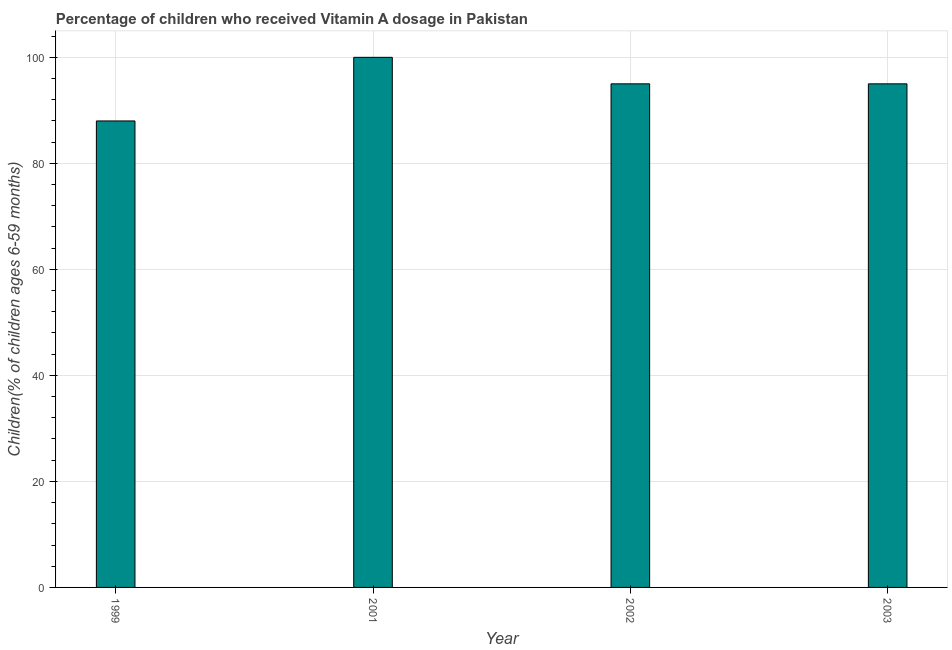Does the graph contain grids?
Keep it short and to the point. Yes. What is the title of the graph?
Make the answer very short. Percentage of children who received Vitamin A dosage in Pakistan. What is the label or title of the Y-axis?
Provide a succinct answer. Children(% of children ages 6-59 months). What is the vitamin a supplementation coverage rate in 2001?
Offer a terse response. 100. In which year was the vitamin a supplementation coverage rate minimum?
Provide a succinct answer. 1999. What is the sum of the vitamin a supplementation coverage rate?
Provide a succinct answer. 378. What is the difference between the vitamin a supplementation coverage rate in 2002 and 2003?
Your answer should be very brief. 0. What is the average vitamin a supplementation coverage rate per year?
Your response must be concise. 94. What is the median vitamin a supplementation coverage rate?
Your answer should be very brief. 95. Do a majority of the years between 1999 and 2003 (inclusive) have vitamin a supplementation coverage rate greater than 32 %?
Your response must be concise. Yes. What is the ratio of the vitamin a supplementation coverage rate in 2001 to that in 2003?
Make the answer very short. 1.05. What is the difference between the highest and the second highest vitamin a supplementation coverage rate?
Keep it short and to the point. 5. Is the sum of the vitamin a supplementation coverage rate in 1999 and 2003 greater than the maximum vitamin a supplementation coverage rate across all years?
Your response must be concise. Yes. In how many years, is the vitamin a supplementation coverage rate greater than the average vitamin a supplementation coverage rate taken over all years?
Provide a short and direct response. 3. Are all the bars in the graph horizontal?
Make the answer very short. No. What is the difference between two consecutive major ticks on the Y-axis?
Keep it short and to the point. 20. Are the values on the major ticks of Y-axis written in scientific E-notation?
Make the answer very short. No. What is the Children(% of children ages 6-59 months) of 1999?
Offer a very short reply. 88. What is the Children(% of children ages 6-59 months) in 2003?
Your response must be concise. 95. What is the difference between the Children(% of children ages 6-59 months) in 1999 and 2001?
Provide a succinct answer. -12. What is the difference between the Children(% of children ages 6-59 months) in 2001 and 2003?
Provide a succinct answer. 5. What is the difference between the Children(% of children ages 6-59 months) in 2002 and 2003?
Offer a terse response. 0. What is the ratio of the Children(% of children ages 6-59 months) in 1999 to that in 2002?
Give a very brief answer. 0.93. What is the ratio of the Children(% of children ages 6-59 months) in 1999 to that in 2003?
Ensure brevity in your answer.  0.93. What is the ratio of the Children(% of children ages 6-59 months) in 2001 to that in 2002?
Your answer should be compact. 1.05. What is the ratio of the Children(% of children ages 6-59 months) in 2001 to that in 2003?
Keep it short and to the point. 1.05. 